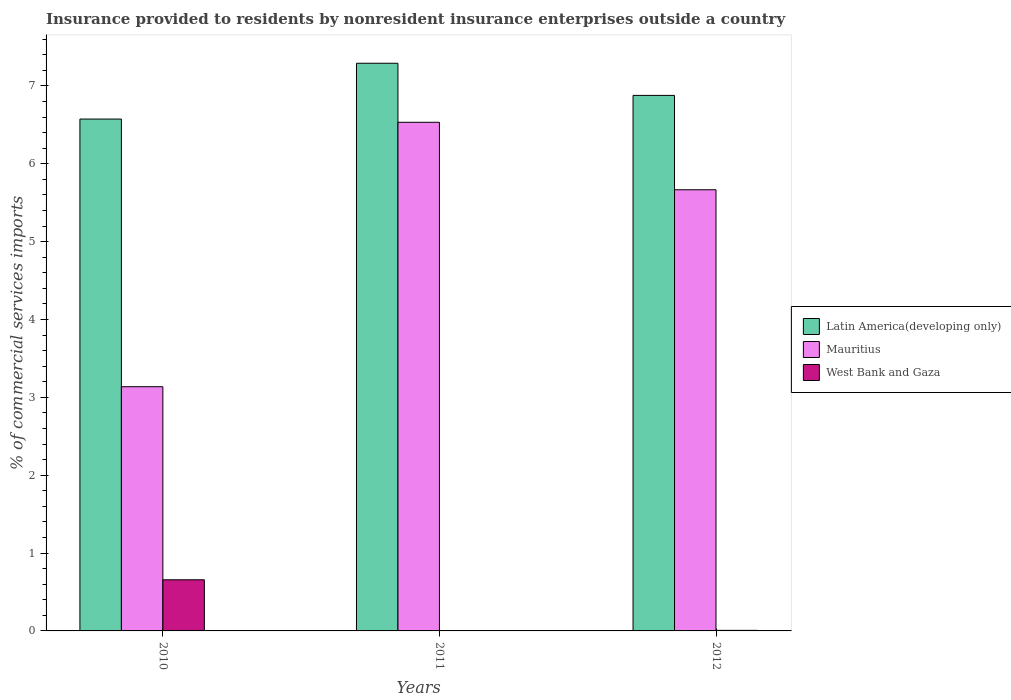How many groups of bars are there?
Your answer should be compact. 3. What is the label of the 3rd group of bars from the left?
Your response must be concise. 2012. In how many cases, is the number of bars for a given year not equal to the number of legend labels?
Offer a terse response. 0. What is the Insurance provided to residents in West Bank and Gaza in 2011?
Offer a terse response. 0. Across all years, what is the maximum Insurance provided to residents in West Bank and Gaza?
Give a very brief answer. 0.66. Across all years, what is the minimum Insurance provided to residents in Latin America(developing only)?
Your answer should be very brief. 6.57. In which year was the Insurance provided to residents in West Bank and Gaza maximum?
Provide a short and direct response. 2010. What is the total Insurance provided to residents in Latin America(developing only) in the graph?
Make the answer very short. 20.74. What is the difference between the Insurance provided to residents in West Bank and Gaza in 2011 and that in 2012?
Offer a very short reply. -0. What is the difference between the Insurance provided to residents in West Bank and Gaza in 2011 and the Insurance provided to residents in Mauritius in 2012?
Offer a terse response. -5.66. What is the average Insurance provided to residents in Mauritius per year?
Provide a succinct answer. 5.11. In the year 2010, what is the difference between the Insurance provided to residents in Mauritius and Insurance provided to residents in West Bank and Gaza?
Your answer should be compact. 2.48. What is the ratio of the Insurance provided to residents in Mauritius in 2010 to that in 2011?
Make the answer very short. 0.48. Is the Insurance provided to residents in Mauritius in 2010 less than that in 2011?
Your answer should be very brief. Yes. What is the difference between the highest and the second highest Insurance provided to residents in West Bank and Gaza?
Your answer should be very brief. 0.65. What is the difference between the highest and the lowest Insurance provided to residents in Latin America(developing only)?
Make the answer very short. 0.72. In how many years, is the Insurance provided to residents in Latin America(developing only) greater than the average Insurance provided to residents in Latin America(developing only) taken over all years?
Your response must be concise. 1. What does the 2nd bar from the left in 2012 represents?
Keep it short and to the point. Mauritius. What does the 3rd bar from the right in 2011 represents?
Your answer should be compact. Latin America(developing only). Is it the case that in every year, the sum of the Insurance provided to residents in West Bank and Gaza and Insurance provided to residents in Latin America(developing only) is greater than the Insurance provided to residents in Mauritius?
Provide a succinct answer. Yes. How many bars are there?
Keep it short and to the point. 9. How many years are there in the graph?
Your response must be concise. 3. What is the difference between two consecutive major ticks on the Y-axis?
Offer a very short reply. 1. Are the values on the major ticks of Y-axis written in scientific E-notation?
Your answer should be very brief. No. Does the graph contain grids?
Provide a succinct answer. No. How many legend labels are there?
Give a very brief answer. 3. What is the title of the graph?
Your response must be concise. Insurance provided to residents by nonresident insurance enterprises outside a country. Does "Kiribati" appear as one of the legend labels in the graph?
Provide a succinct answer. No. What is the label or title of the Y-axis?
Your response must be concise. % of commercial services imports. What is the % of commercial services imports of Latin America(developing only) in 2010?
Offer a very short reply. 6.57. What is the % of commercial services imports in Mauritius in 2010?
Your answer should be compact. 3.14. What is the % of commercial services imports in West Bank and Gaza in 2010?
Your answer should be compact. 0.66. What is the % of commercial services imports of Latin America(developing only) in 2011?
Your response must be concise. 7.29. What is the % of commercial services imports in Mauritius in 2011?
Provide a short and direct response. 6.53. What is the % of commercial services imports in West Bank and Gaza in 2011?
Your response must be concise. 0. What is the % of commercial services imports of Latin America(developing only) in 2012?
Your answer should be very brief. 6.88. What is the % of commercial services imports in Mauritius in 2012?
Provide a succinct answer. 5.67. What is the % of commercial services imports in West Bank and Gaza in 2012?
Provide a short and direct response. 0.01. Across all years, what is the maximum % of commercial services imports of Latin America(developing only)?
Provide a succinct answer. 7.29. Across all years, what is the maximum % of commercial services imports in Mauritius?
Your response must be concise. 6.53. Across all years, what is the maximum % of commercial services imports of West Bank and Gaza?
Your answer should be very brief. 0.66. Across all years, what is the minimum % of commercial services imports in Latin America(developing only)?
Ensure brevity in your answer.  6.57. Across all years, what is the minimum % of commercial services imports of Mauritius?
Offer a terse response. 3.14. Across all years, what is the minimum % of commercial services imports of West Bank and Gaza?
Offer a very short reply. 0. What is the total % of commercial services imports in Latin America(developing only) in the graph?
Offer a very short reply. 20.74. What is the total % of commercial services imports of Mauritius in the graph?
Provide a succinct answer. 15.34. What is the total % of commercial services imports in West Bank and Gaza in the graph?
Give a very brief answer. 0.67. What is the difference between the % of commercial services imports in Latin America(developing only) in 2010 and that in 2011?
Keep it short and to the point. -0.72. What is the difference between the % of commercial services imports in Mauritius in 2010 and that in 2011?
Ensure brevity in your answer.  -3.4. What is the difference between the % of commercial services imports of West Bank and Gaza in 2010 and that in 2011?
Ensure brevity in your answer.  0.65. What is the difference between the % of commercial services imports of Latin America(developing only) in 2010 and that in 2012?
Keep it short and to the point. -0.3. What is the difference between the % of commercial services imports in Mauritius in 2010 and that in 2012?
Ensure brevity in your answer.  -2.53. What is the difference between the % of commercial services imports of West Bank and Gaza in 2010 and that in 2012?
Give a very brief answer. 0.65. What is the difference between the % of commercial services imports of Latin America(developing only) in 2011 and that in 2012?
Offer a very short reply. 0.41. What is the difference between the % of commercial services imports of Mauritius in 2011 and that in 2012?
Keep it short and to the point. 0.87. What is the difference between the % of commercial services imports of West Bank and Gaza in 2011 and that in 2012?
Give a very brief answer. -0. What is the difference between the % of commercial services imports of Latin America(developing only) in 2010 and the % of commercial services imports of Mauritius in 2011?
Give a very brief answer. 0.04. What is the difference between the % of commercial services imports in Latin America(developing only) in 2010 and the % of commercial services imports in West Bank and Gaza in 2011?
Offer a terse response. 6.57. What is the difference between the % of commercial services imports of Mauritius in 2010 and the % of commercial services imports of West Bank and Gaza in 2011?
Offer a very short reply. 3.13. What is the difference between the % of commercial services imports of Latin America(developing only) in 2010 and the % of commercial services imports of Mauritius in 2012?
Your answer should be very brief. 0.91. What is the difference between the % of commercial services imports in Latin America(developing only) in 2010 and the % of commercial services imports in West Bank and Gaza in 2012?
Keep it short and to the point. 6.57. What is the difference between the % of commercial services imports of Mauritius in 2010 and the % of commercial services imports of West Bank and Gaza in 2012?
Ensure brevity in your answer.  3.13. What is the difference between the % of commercial services imports in Latin America(developing only) in 2011 and the % of commercial services imports in Mauritius in 2012?
Your answer should be very brief. 1.62. What is the difference between the % of commercial services imports of Latin America(developing only) in 2011 and the % of commercial services imports of West Bank and Gaza in 2012?
Your answer should be very brief. 7.28. What is the difference between the % of commercial services imports of Mauritius in 2011 and the % of commercial services imports of West Bank and Gaza in 2012?
Give a very brief answer. 6.53. What is the average % of commercial services imports in Latin America(developing only) per year?
Your answer should be very brief. 6.92. What is the average % of commercial services imports of Mauritius per year?
Provide a succinct answer. 5.11. What is the average % of commercial services imports in West Bank and Gaza per year?
Offer a terse response. 0.22. In the year 2010, what is the difference between the % of commercial services imports of Latin America(developing only) and % of commercial services imports of Mauritius?
Provide a short and direct response. 3.44. In the year 2010, what is the difference between the % of commercial services imports in Latin America(developing only) and % of commercial services imports in West Bank and Gaza?
Keep it short and to the point. 5.92. In the year 2010, what is the difference between the % of commercial services imports of Mauritius and % of commercial services imports of West Bank and Gaza?
Provide a short and direct response. 2.48. In the year 2011, what is the difference between the % of commercial services imports of Latin America(developing only) and % of commercial services imports of Mauritius?
Keep it short and to the point. 0.76. In the year 2011, what is the difference between the % of commercial services imports in Latin America(developing only) and % of commercial services imports in West Bank and Gaza?
Provide a short and direct response. 7.29. In the year 2011, what is the difference between the % of commercial services imports in Mauritius and % of commercial services imports in West Bank and Gaza?
Provide a short and direct response. 6.53. In the year 2012, what is the difference between the % of commercial services imports in Latin America(developing only) and % of commercial services imports in Mauritius?
Your response must be concise. 1.21. In the year 2012, what is the difference between the % of commercial services imports of Latin America(developing only) and % of commercial services imports of West Bank and Gaza?
Give a very brief answer. 6.87. In the year 2012, what is the difference between the % of commercial services imports of Mauritius and % of commercial services imports of West Bank and Gaza?
Provide a succinct answer. 5.66. What is the ratio of the % of commercial services imports in Latin America(developing only) in 2010 to that in 2011?
Keep it short and to the point. 0.9. What is the ratio of the % of commercial services imports of Mauritius in 2010 to that in 2011?
Offer a terse response. 0.48. What is the ratio of the % of commercial services imports of West Bank and Gaza in 2010 to that in 2011?
Offer a very short reply. 148.91. What is the ratio of the % of commercial services imports in Latin America(developing only) in 2010 to that in 2012?
Your response must be concise. 0.96. What is the ratio of the % of commercial services imports in Mauritius in 2010 to that in 2012?
Your answer should be compact. 0.55. What is the ratio of the % of commercial services imports in West Bank and Gaza in 2010 to that in 2012?
Make the answer very short. 89.33. What is the ratio of the % of commercial services imports of Latin America(developing only) in 2011 to that in 2012?
Offer a very short reply. 1.06. What is the ratio of the % of commercial services imports of Mauritius in 2011 to that in 2012?
Offer a terse response. 1.15. What is the ratio of the % of commercial services imports in West Bank and Gaza in 2011 to that in 2012?
Give a very brief answer. 0.6. What is the difference between the highest and the second highest % of commercial services imports of Latin America(developing only)?
Keep it short and to the point. 0.41. What is the difference between the highest and the second highest % of commercial services imports of Mauritius?
Make the answer very short. 0.87. What is the difference between the highest and the second highest % of commercial services imports in West Bank and Gaza?
Your answer should be very brief. 0.65. What is the difference between the highest and the lowest % of commercial services imports of Latin America(developing only)?
Provide a succinct answer. 0.72. What is the difference between the highest and the lowest % of commercial services imports of Mauritius?
Ensure brevity in your answer.  3.4. What is the difference between the highest and the lowest % of commercial services imports of West Bank and Gaza?
Provide a short and direct response. 0.65. 